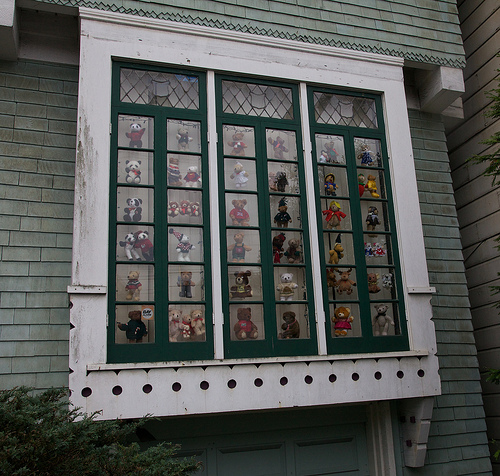<image>
Is the panda above the bush? Yes. The panda is positioned above the bush in the vertical space, higher up in the scene. Is the bear in front of the window? No. The bear is not in front of the window. The spatial positioning shows a different relationship between these objects. 